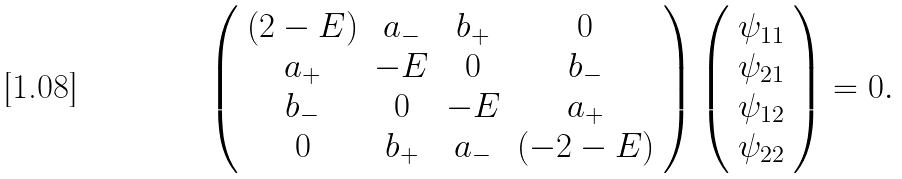<formula> <loc_0><loc_0><loc_500><loc_500>\left ( \begin{array} { c c c c } ( 2 - E ) & a _ { - } & b _ { + } & 0 \\ a _ { + } & - E & 0 & b _ { - } \\ b _ { - } & 0 & - E & a _ { + } \\ 0 & b _ { + } & a _ { - } & ( - 2 - E ) \end{array} \right ) \left ( \begin{array} { c } \psi _ { 1 1 } \\ \psi _ { 2 1 } \\ \psi _ { 1 2 } \\ \psi _ { 2 2 } \end{array} \right ) = 0 .</formula> 